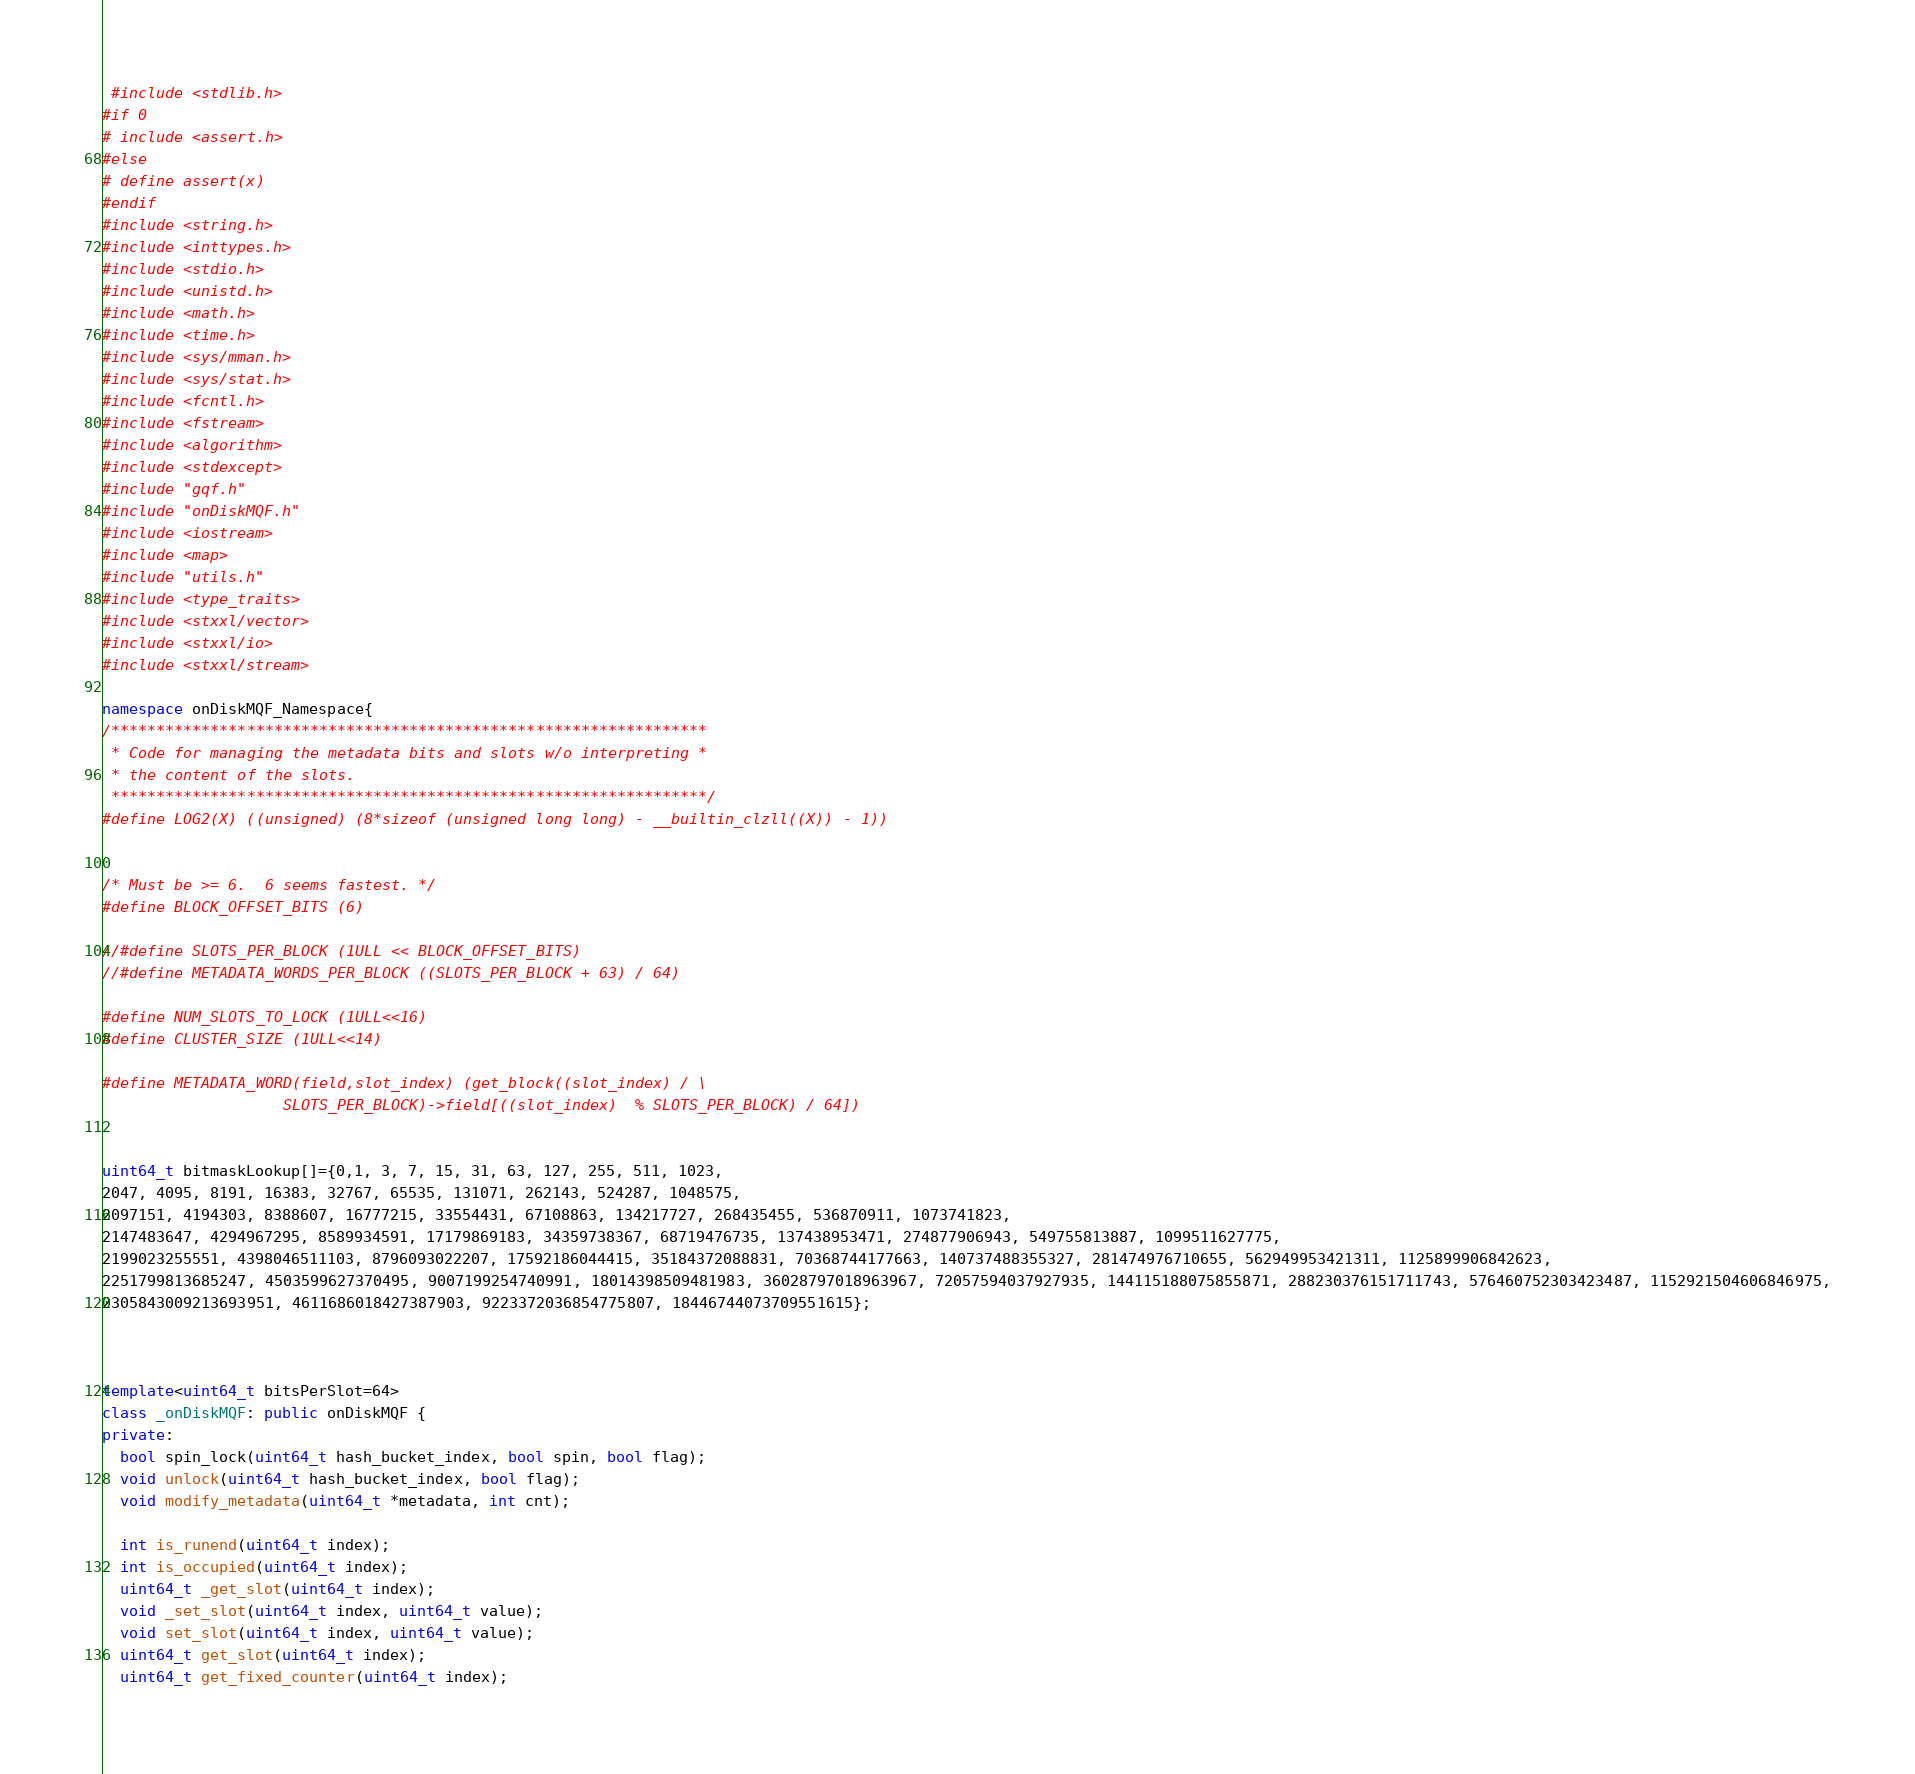<code> <loc_0><loc_0><loc_500><loc_500><_C++_> #include <stdlib.h>
#if 0
# include <assert.h>
#else
# define assert(x)
#endif
#include <string.h>
#include <inttypes.h>
#include <stdio.h>
#include <unistd.h>
#include <math.h>
#include <time.h>
#include <sys/mman.h>
#include <sys/stat.h>
#include <fcntl.h>
#include <fstream>
#include <algorithm>
#include <stdexcept>
#include "gqf.h"
#include "onDiskMQF.h"
#include <iostream>
#include <map>
#include "utils.h"
#include <type_traits>
#include <stxxl/vector>
#include <stxxl/io>
#include <stxxl/stream>

namespace onDiskMQF_Namespace{
/******************************************************************
 * Code for managing the metadata bits and slots w/o interpreting *
 * the content of the slots.
 ******************************************************************/
#define LOG2(X) ((unsigned) (8*sizeof (unsigned long long) - __builtin_clzll((X)) - 1))


/* Must be >= 6.  6 seems fastest. */
#define BLOCK_OFFSET_BITS (6)

//#define SLOTS_PER_BLOCK (1ULL << BLOCK_OFFSET_BITS)
//#define METADATA_WORDS_PER_BLOCK ((SLOTS_PER_BLOCK + 63) / 64)

#define NUM_SLOTS_TO_LOCK (1ULL<<16)
#define CLUSTER_SIZE (1ULL<<14)

#define METADATA_WORD(field,slot_index) (get_block((slot_index) / \
					SLOTS_PER_BLOCK)->field[((slot_index)  % SLOTS_PER_BLOCK) / 64])


uint64_t bitmaskLookup[]={0,1, 3, 7, 15, 31, 63, 127, 255, 511, 1023,
2047, 4095, 8191, 16383, 32767, 65535, 131071, 262143, 524287, 1048575,
2097151, 4194303, 8388607, 16777215, 33554431, 67108863, 134217727, 268435455, 536870911, 1073741823,
2147483647, 4294967295, 8589934591, 17179869183, 34359738367, 68719476735, 137438953471, 274877906943, 549755813887, 1099511627775,
2199023255551, 4398046511103, 8796093022207, 17592186044415, 35184372088831, 70368744177663, 140737488355327, 281474976710655, 562949953421311, 1125899906842623,
2251799813685247, 4503599627370495, 9007199254740991, 18014398509481983, 36028797018963967, 72057594037927935, 144115188075855871, 288230376151711743, 576460752303423487, 1152921504606846975,
2305843009213693951, 4611686018427387903, 9223372036854775807, 18446744073709551615};



template<uint64_t bitsPerSlot=64>
class _onDiskMQF: public onDiskMQF {
private:
  bool spin_lock(uint64_t hash_bucket_index, bool spin, bool flag);
  void unlock(uint64_t hash_bucket_index, bool flag);
  void modify_metadata(uint64_t *metadata, int cnt);

  int is_runend(uint64_t index);
  int is_occupied(uint64_t index);
  uint64_t _get_slot(uint64_t index);
  void _set_slot(uint64_t index, uint64_t value);
  void set_slot(uint64_t index, uint64_t value);
  uint64_t get_slot(uint64_t index);
  uint64_t get_fixed_counter(uint64_t index);</code> 